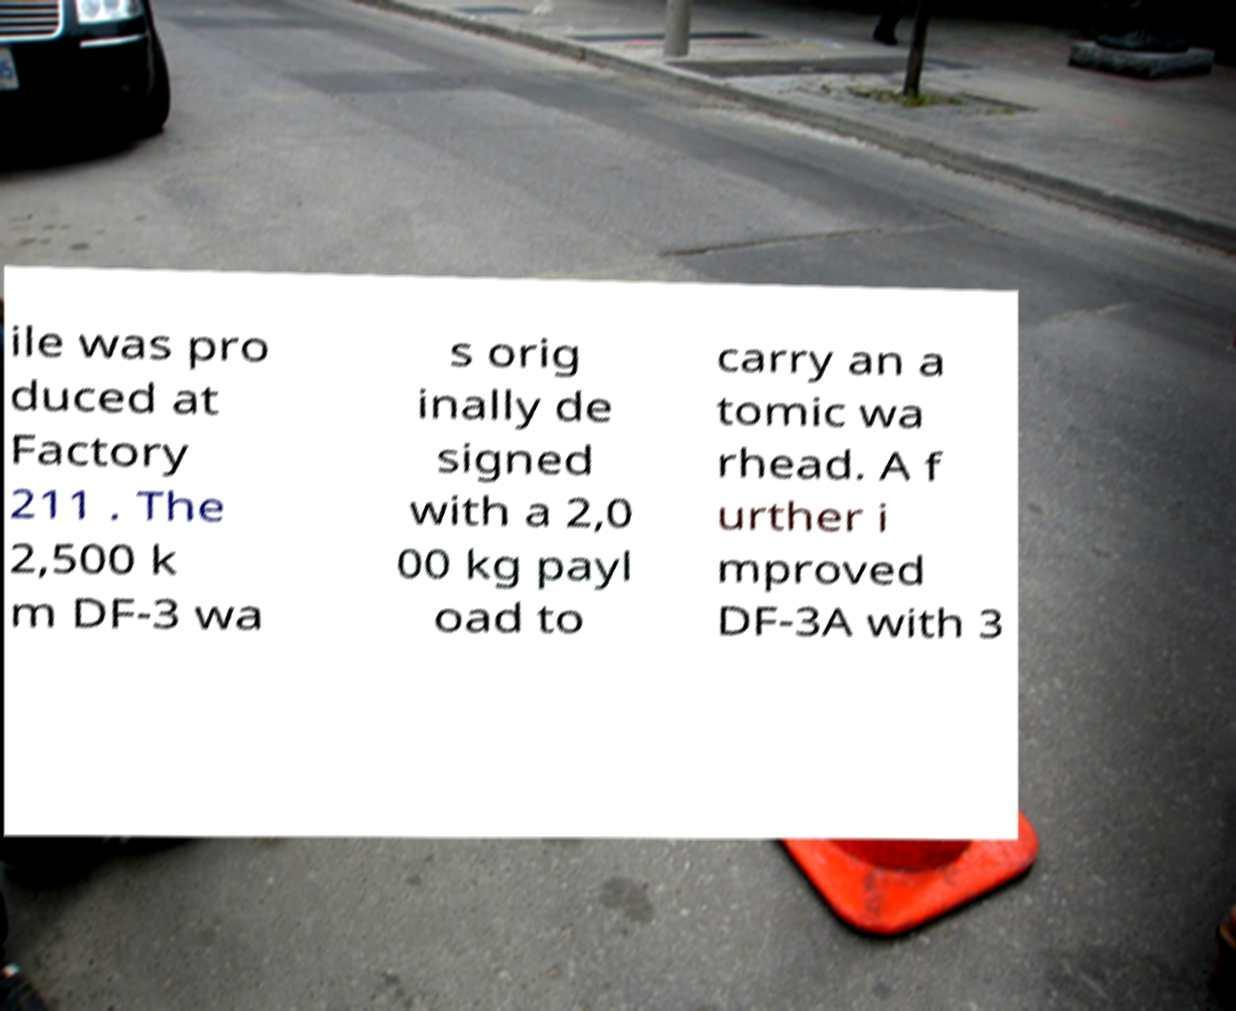Could you assist in decoding the text presented in this image and type it out clearly? ile was pro duced at Factory 211 . The 2,500 k m DF-3 wa s orig inally de signed with a 2,0 00 kg payl oad to carry an a tomic wa rhead. A f urther i mproved DF-3A with 3 